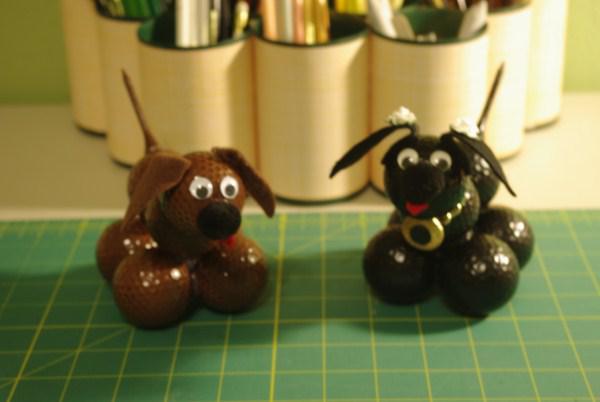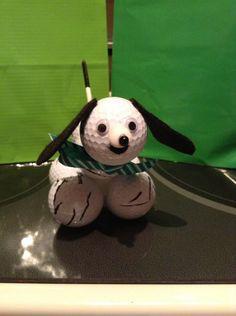The first image is the image on the left, the second image is the image on the right. For the images displayed, is the sentence "All the golf balls are white." factually correct? Answer yes or no. No. 